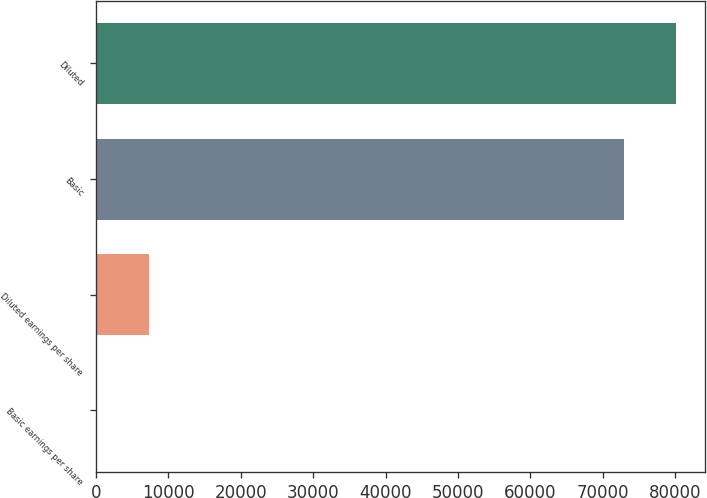Convert chart. <chart><loc_0><loc_0><loc_500><loc_500><bar_chart><fcel>Basic earnings per share<fcel>Diluted earnings per share<fcel>Basic<fcel>Diluted<nl><fcel>0.31<fcel>7290.18<fcel>72899<fcel>80188.9<nl></chart> 